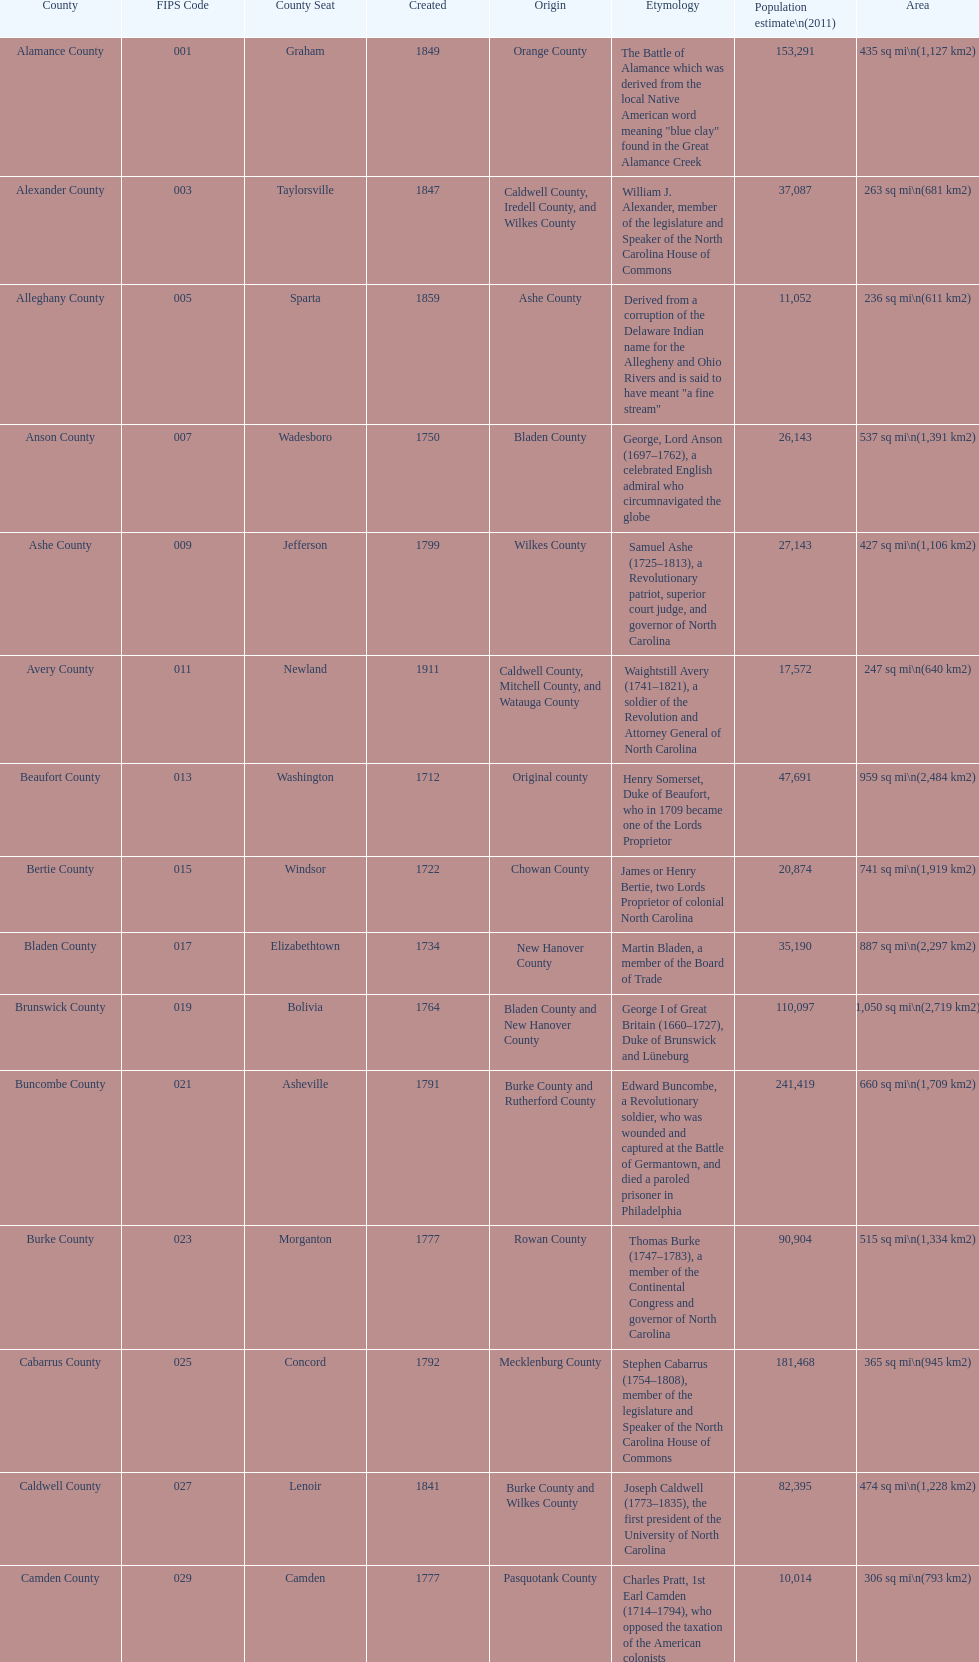What is the total number of counties listed? 100. 